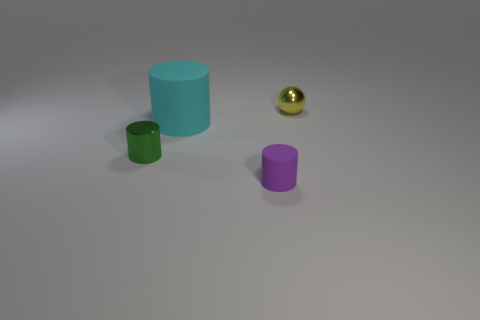Subtract all cyan cylinders. How many cylinders are left? 2 Add 1 gray matte things. How many objects exist? 5 Subtract all purple cylinders. How many cylinders are left? 2 Add 3 small purple metallic cylinders. How many small purple metallic cylinders exist? 3 Subtract 1 green cylinders. How many objects are left? 3 Subtract all spheres. How many objects are left? 3 Subtract 1 cylinders. How many cylinders are left? 2 Subtract all cyan spheres. Subtract all green blocks. How many spheres are left? 1 Subtract all gray cylinders. How many blue spheres are left? 0 Subtract all blue matte cubes. Subtract all cylinders. How many objects are left? 1 